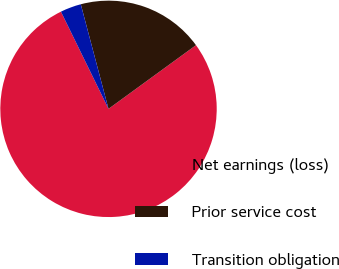Convert chart to OTSL. <chart><loc_0><loc_0><loc_500><loc_500><pie_chart><fcel>Net earnings (loss)<fcel>Prior service cost<fcel>Transition obligation<nl><fcel>77.78%<fcel>19.11%<fcel>3.12%<nl></chart> 